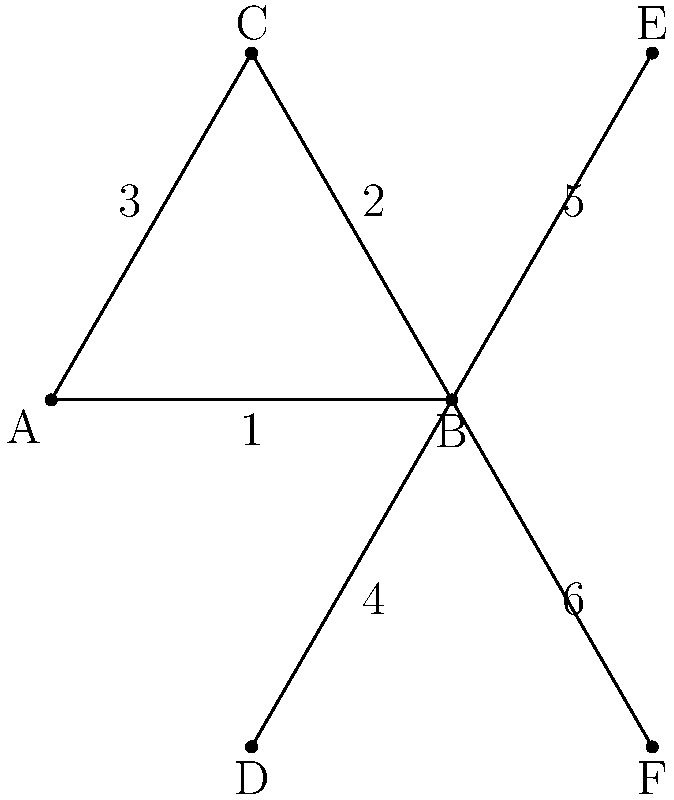In the stick figure representation of a skater's leg positions during various moves, angles are formed at point B. If angle 1 is 60°, what is the measure of angle 5? Let's approach this step-by-step:

1) First, we need to recognize that the triangle ABC is equilateral. This is because:
   - Angle 1 is given as 60°
   - In an equilateral triangle, all angles are 60°

2) In an equilateral triangle, all sides are equal. This means that AB = BC = AC.

3) Now, let's look at the line BE. It extends from point B through point C and beyond.

4) Because ABC is equilateral, BE bisects angle ABC.

5) When a line bisects an angle of an equilateral triangle, it creates two 30° angles.

6) Therefore, angle CBE (angle 5) is half of angle ABC.

7) We know that angle ABC = 60° (as it's an equilateral triangle)

8) So, angle CBE (angle 5) = 60° ÷ 2 = 30°

Thus, the measure of angle 5 is 30°.
Answer: $30°$ 